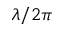<formula> <loc_0><loc_0><loc_500><loc_500>\lambda / 2 \pi</formula> 